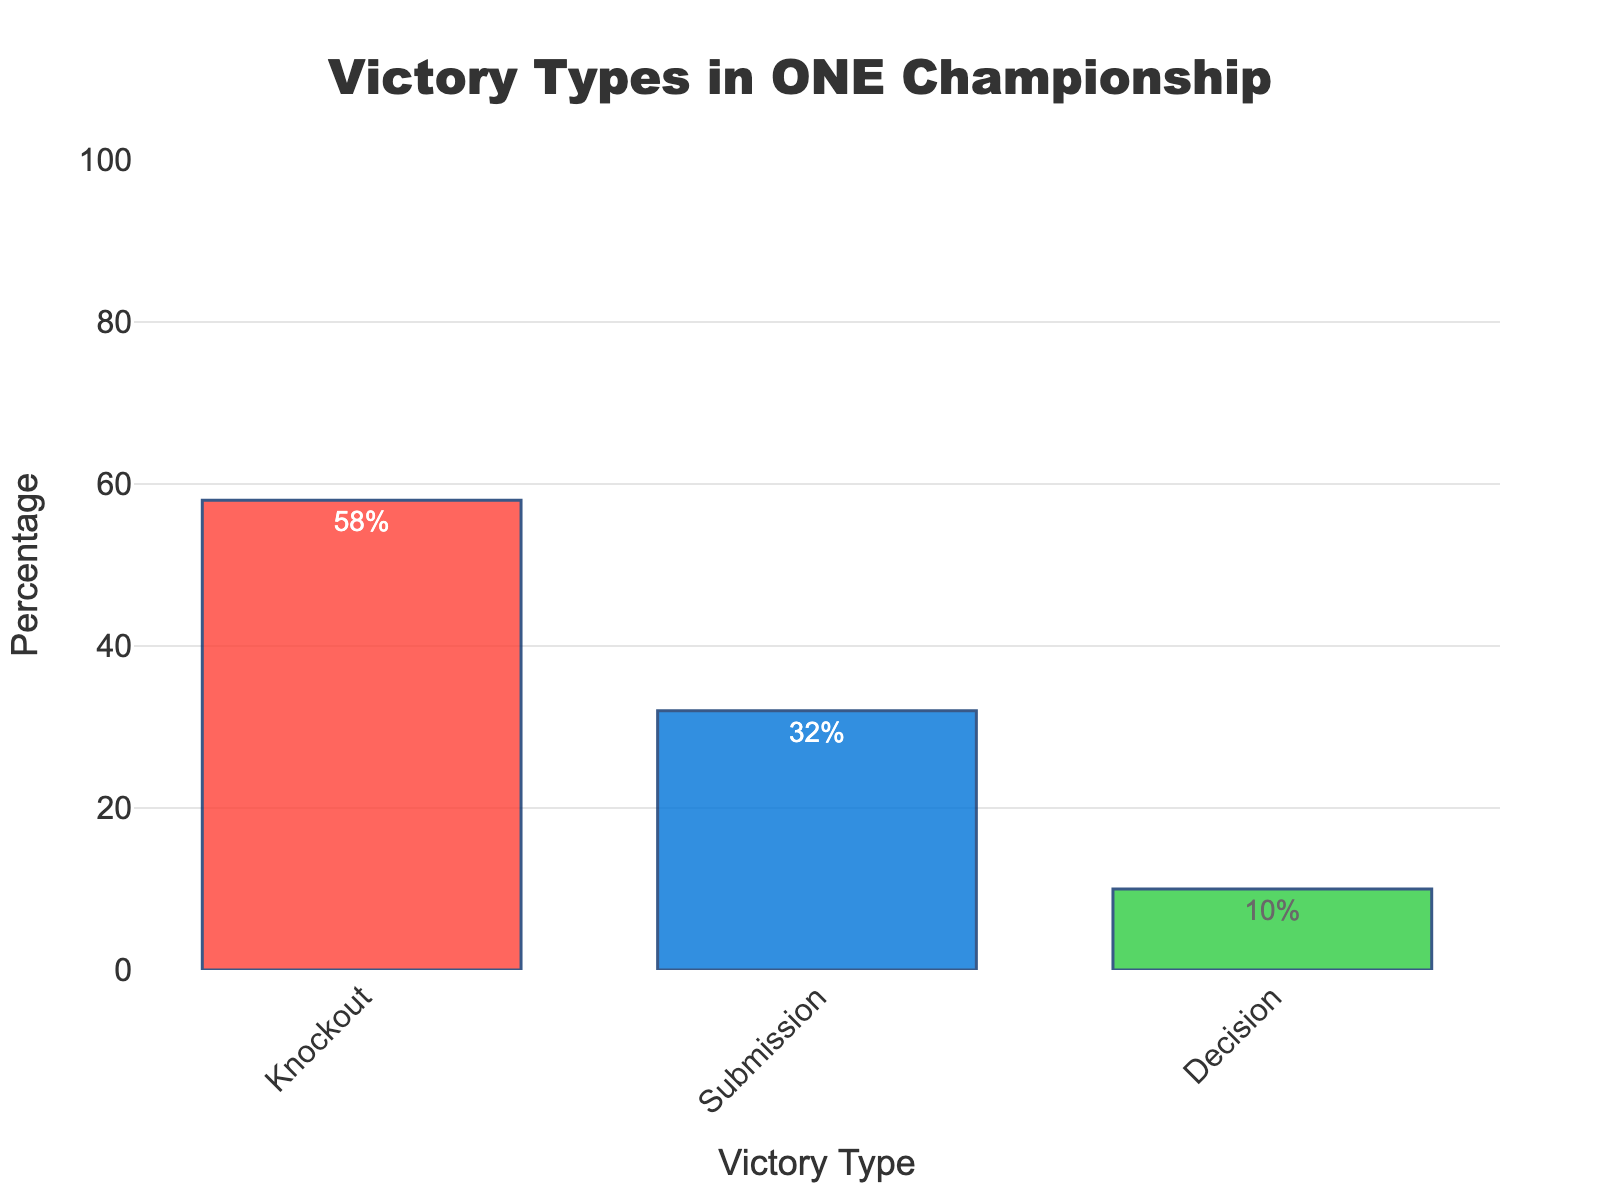Which victory type is the most common in ONE Championship events? The 'Knockout' bar is the tallest among the three, indicating it is the most common victory type.
Answer: Knockout What is the difference in percentage between Knockout and Submission victories? The percentage for Knockout is 58% and for Submission is 32%. The difference is 58% - 32% = 26%.
Answer: 26% Which victory type is the least common? The 'Decision' bar is the shortest, showing that Decision is the least common victory type.
Answer: Decision What percentage of victories is not achieved by Knockout? The total percentage is 100%. Knockout victories account for 58%. Thus, 100% - 58% = 42% of victories are not Knockout.
Answer: 42% How much higher is the Knockout victory percentage compared to the Decision victory percentage? The percentage for Knockout is 58%, and for Decision, it is 10%. The difference is 58% - 10% = 48%.
Answer: 48% What is the average percentage of Submission and Decision victories? The percentages are 32% for Submission and 10% for Decision. The average is (32% + 10%) / 2 = 21%.
Answer: 21% If a fight results in a victory in the ONE Championship, what is the likelihood that it was by Submission? There are three victory types with percentages adding up to 100%. Submission victories are 32%. Thus, the likelihood is 32%.
Answer: 32% Are there more Submission victories than the combined total of Decision victories and half of Knockout victories? Submission victories are 32%. Decision victories are 10%, and half of Knockout victories are 58% / 2 = 29%. The combined total is 10% + 29% = 39%, which is higher than 32%.
Answer: No What is the combined percentage of Knockout and Decision victories? The Knockout percentage is 58% and the Decision percentage is 10%. The combined percentage is 58% + 10% = 68%.
Answer: 68% How many times more frequent are Knockout victories compared to Decision victories? Knockout victories are 58%, and Decision victories are 10%. The ratio is 58% / 10% = 5.8. So, Knockout victories are 5.8 times more frequent.
Answer: 5.8 